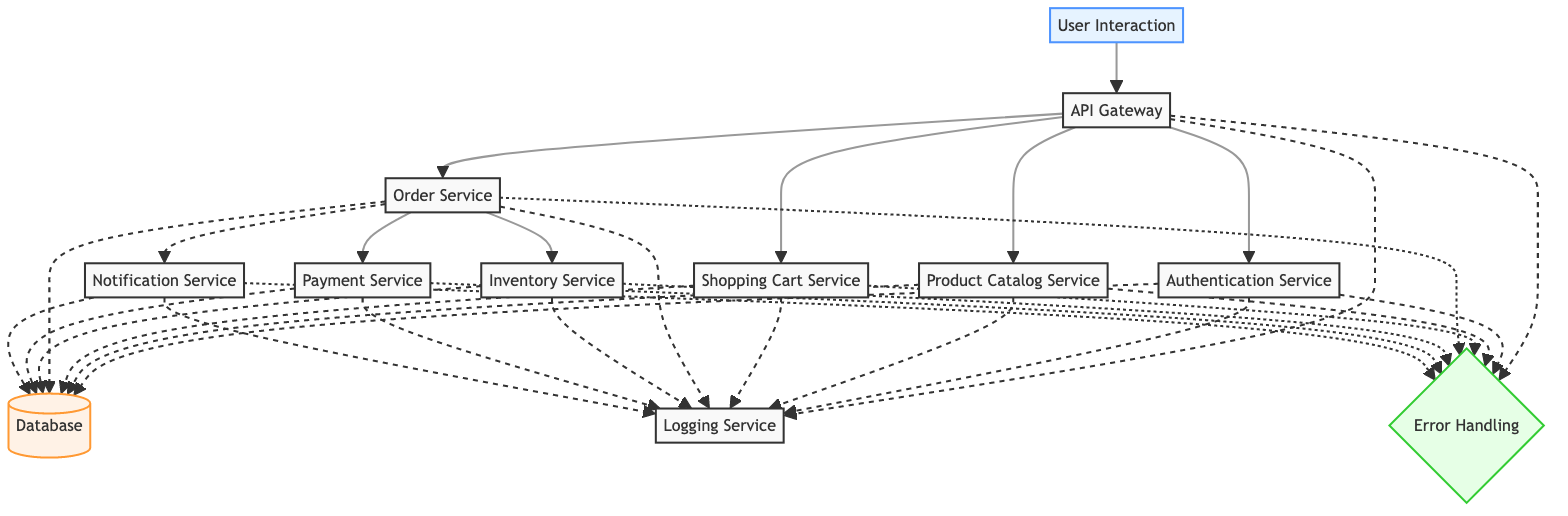What is the first step in the workflow? The first step, indicated by the input node, is "User Interaction," which shows that the customer starts the purchase process in the retail application.
Answer: User Interaction How many services are present in the diagram? By counting all the nodes categorized as "service," we find there are 9 distinct services, including the API Gateway and various other services involved in processing orders.
Answer: 9 Which service is responsible for processing payments? The "Payment Service" is explicitly mentioned in the diagram as the component that handles payment processing and verifies transaction details.
Answer: Payment Service What service interacts with the Shopping Cart Service? In the diagram, the "API Gateway" routes requests to the "Shopping Cart Service," which is essential for managing items in the user's shopping cart.
Answer: API Gateway How do users authenticate themselves in this workflow? Users authenticate themselves through the "Authentication Service," which validates their credentials and issues authentication tokens, before they can proceed to further services.
Answer: Authentication Service What happens after the Order Service completes an order? Following the completion of an order by the "Order Service," it triggers the "Notification Service" to send order confirmation and status updates to the customer.
Answer: Notification Service What types of errors are logged in the workflow? Both the "API Gateway" and all service nodes are linked to the "Error Handling" process in the diagram, indicating that error logging occurs for any issues encountered throughout the workflow.
Answer: Any What is the role of the Inventory Service? The "Inventory Service" is responsible for checking product availability and updating inventory levels to ensure that the stock is accurately reflected after sales are made.
Answer: Checks product availability Which node connects the Payment Service to the Database? The link between the "Payment Service" and the "Database" is represented as a dashed line, indicating that the payment service interacts with the database for transaction verification and data storage.
Answer: Database 